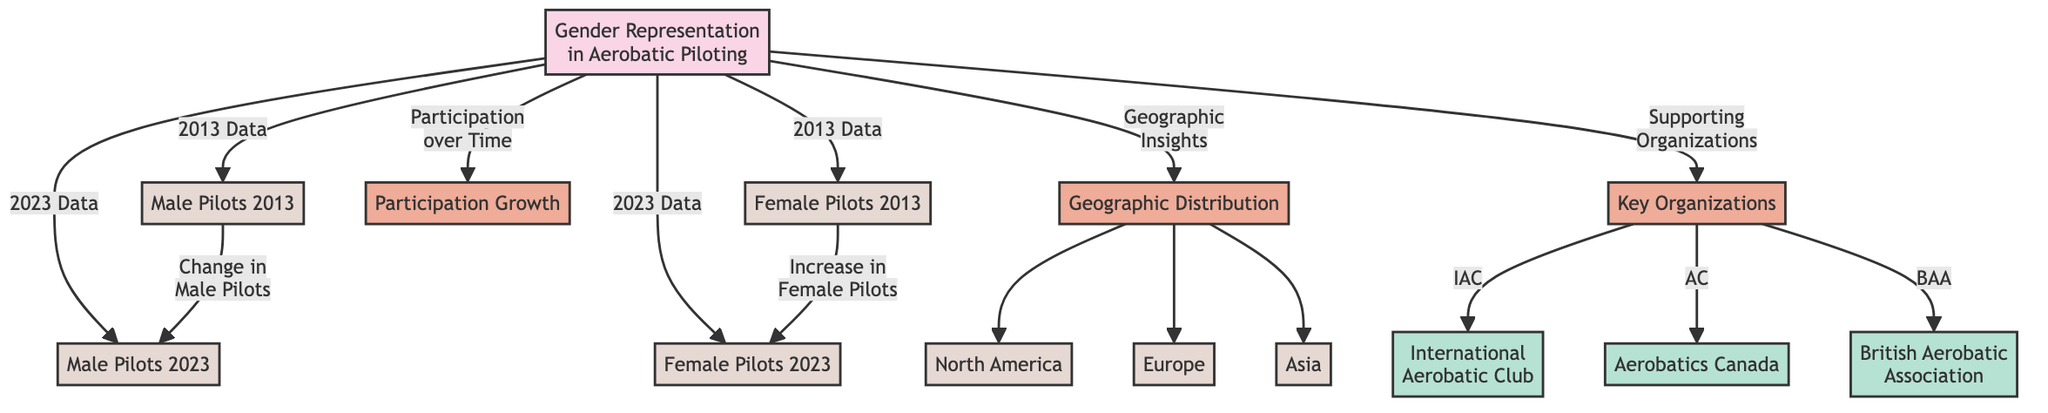What is the total number of pilot categories represented in the diagram? The diagram has three main categories for pilots: Male Pilots, Female Pilots, and Participation Growth, with additional subcategories related to Geographic Distribution and Key Organizations. Counting all, we have two data nodes for each gender in 2013 and 2023, making a total of four data points specifically for pilots, but when including the subcategories, we have six unique sections, though they're not entirely separate groups. Hence, the answer is six.
Answer: 6 How many male pilots were there in 2013? The node labeled "Male Pilots 2013" directly provides this data point. This node indicates the number of male pilots as stated in the diagram itself.
Answer: Male Pilots 2013 How many female pilots were there in 2023? Similarly, the node "Female Pilots 2023" provides the specific data point for female pilots in 2023. This node confirms the number as explicitly indicated in the diagram.
Answer: Female Pilots 2023 Which region is mentioned first under Geographic Distribution? The first region mentioned in the Geographic Distribution section is North America, as indicated by the flow from the Geographic Distribution node to the specific data nodes representing each region.
Answer: North America Is there an increase or decrease in female pilots from 2013 to 2023? The diagram connects the "Female Pilots 2013" node to the "Female Pilots 2023" node, with a note stating "Increase in Female Pilots," indicating that there has been growth in female pilot numbers during that period.
Answer: Increase How many key organizations are listed in the diagram? The "Key Organizations" subcategory branches out into three specific organizations: International Aerobatic Club, Aerobatics Canada, and British Aerobatic Association. Therefore, counting these, we find there are three listed organizations.
Answer: 3 What is the relationship shown between Male Pilots in 2013 and 2023? The flow from "Male Pilots 2013" to "Male Pilots 2023" indicates a change in the number of male pilots, leading to a connection that signifies a shift that may include an increase or decrease; it is a direct comparison of those two data points.
Answer: Change What is the overarching theme of the diagram? The top node "Gender Representation in Aerobatic Piloting" indicates that the primary focus of the diagram is on the demographic analysis of male and female pilots over time, explicitly showcasing gender dynamics in this field.
Answer: Gender Representation in Aerobatic Piloting 